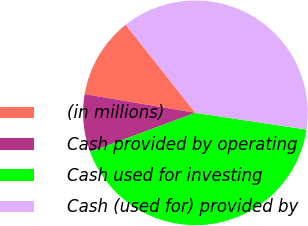Convert chart to OTSL. <chart><loc_0><loc_0><loc_500><loc_500><pie_chart><fcel>(in millions)<fcel>Cash provided by operating<fcel>Cash used for investing<fcel>Cash (used for) provided by<nl><fcel>11.68%<fcel>8.32%<fcel>41.97%<fcel>38.03%<nl></chart> 